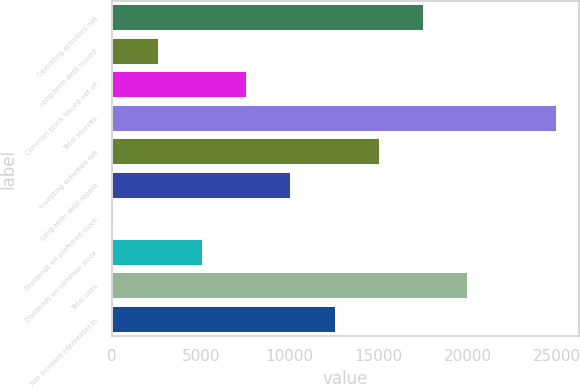Convert chart to OTSL. <chart><loc_0><loc_0><loc_500><loc_500><bar_chart><fcel>Operating activities net<fcel>Long-term debt issued<fcel>Common stock issued net of<fcel>Total sources<fcel>Investing activities net<fcel>Long-term debt repaid<fcel>Dividends on preferred stock<fcel>Dividends on common stock<fcel>Total uses<fcel>Net increase (decrease) in<nl><fcel>17549.2<fcel>2611.6<fcel>7590.8<fcel>25018<fcel>15059.6<fcel>10080.4<fcel>122<fcel>5101.2<fcel>20038.8<fcel>12570<nl></chart> 